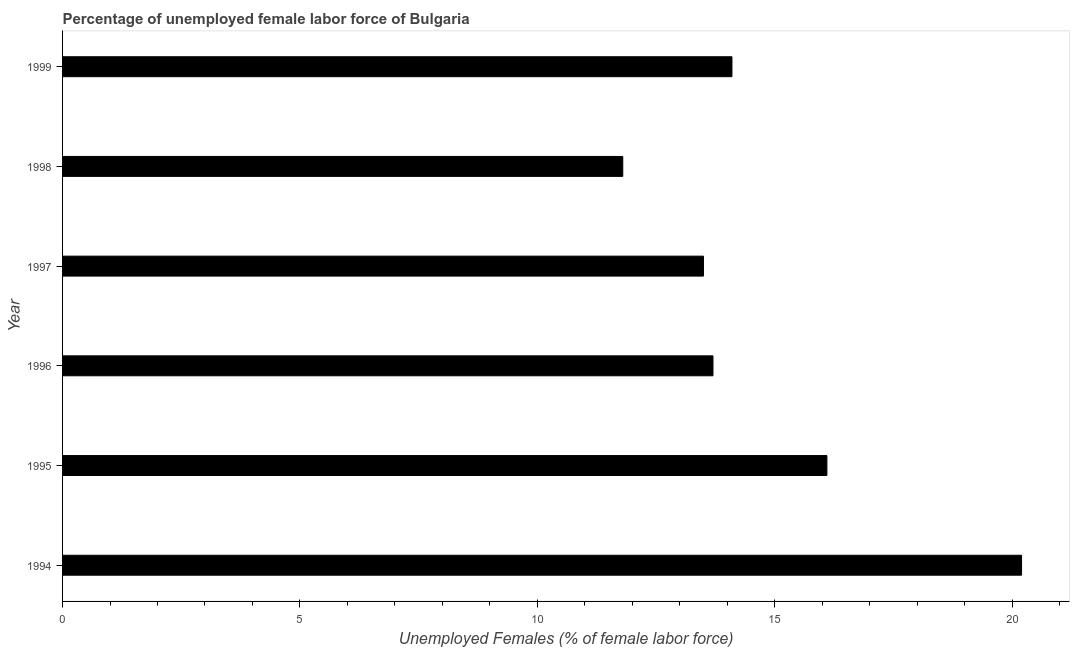Does the graph contain any zero values?
Provide a succinct answer. No. What is the title of the graph?
Provide a short and direct response. Percentage of unemployed female labor force of Bulgaria. What is the label or title of the X-axis?
Provide a short and direct response. Unemployed Females (% of female labor force). What is the total unemployed female labour force in 1998?
Your answer should be compact. 11.8. Across all years, what is the maximum total unemployed female labour force?
Provide a short and direct response. 20.2. Across all years, what is the minimum total unemployed female labour force?
Offer a very short reply. 11.8. In which year was the total unemployed female labour force maximum?
Offer a very short reply. 1994. What is the sum of the total unemployed female labour force?
Make the answer very short. 89.4. What is the average total unemployed female labour force per year?
Provide a short and direct response. 14.9. What is the median total unemployed female labour force?
Give a very brief answer. 13.9. In how many years, is the total unemployed female labour force greater than 4 %?
Ensure brevity in your answer.  6. What is the ratio of the total unemployed female labour force in 1994 to that in 1996?
Keep it short and to the point. 1.47. Is the difference between the total unemployed female labour force in 1996 and 1999 greater than the difference between any two years?
Ensure brevity in your answer.  No. What is the difference between the highest and the second highest total unemployed female labour force?
Your answer should be very brief. 4.1. Is the sum of the total unemployed female labour force in 1997 and 1999 greater than the maximum total unemployed female labour force across all years?
Your response must be concise. Yes. What is the difference between the highest and the lowest total unemployed female labour force?
Your answer should be compact. 8.4. In how many years, is the total unemployed female labour force greater than the average total unemployed female labour force taken over all years?
Offer a terse response. 2. Are all the bars in the graph horizontal?
Give a very brief answer. Yes. What is the difference between two consecutive major ticks on the X-axis?
Give a very brief answer. 5. Are the values on the major ticks of X-axis written in scientific E-notation?
Provide a succinct answer. No. What is the Unemployed Females (% of female labor force) in 1994?
Provide a succinct answer. 20.2. What is the Unemployed Females (% of female labor force) of 1995?
Your answer should be very brief. 16.1. What is the Unemployed Females (% of female labor force) in 1996?
Provide a short and direct response. 13.7. What is the Unemployed Females (% of female labor force) of 1998?
Provide a short and direct response. 11.8. What is the Unemployed Females (% of female labor force) of 1999?
Offer a terse response. 14.1. What is the difference between the Unemployed Females (% of female labor force) in 1994 and 1996?
Provide a succinct answer. 6.5. What is the difference between the Unemployed Females (% of female labor force) in 1994 and 1999?
Provide a succinct answer. 6.1. What is the difference between the Unemployed Females (% of female labor force) in 1995 and 1996?
Offer a terse response. 2.4. What is the difference between the Unemployed Females (% of female labor force) in 1995 and 1997?
Your response must be concise. 2.6. What is the difference between the Unemployed Females (% of female labor force) in 1996 and 1997?
Provide a short and direct response. 0.2. What is the difference between the Unemployed Females (% of female labor force) in 1996 and 1998?
Give a very brief answer. 1.9. What is the difference between the Unemployed Females (% of female labor force) in 1997 and 1998?
Make the answer very short. 1.7. What is the ratio of the Unemployed Females (% of female labor force) in 1994 to that in 1995?
Make the answer very short. 1.25. What is the ratio of the Unemployed Females (% of female labor force) in 1994 to that in 1996?
Give a very brief answer. 1.47. What is the ratio of the Unemployed Females (% of female labor force) in 1994 to that in 1997?
Your response must be concise. 1.5. What is the ratio of the Unemployed Females (% of female labor force) in 1994 to that in 1998?
Your answer should be very brief. 1.71. What is the ratio of the Unemployed Females (% of female labor force) in 1994 to that in 1999?
Offer a terse response. 1.43. What is the ratio of the Unemployed Females (% of female labor force) in 1995 to that in 1996?
Keep it short and to the point. 1.18. What is the ratio of the Unemployed Females (% of female labor force) in 1995 to that in 1997?
Provide a succinct answer. 1.19. What is the ratio of the Unemployed Females (% of female labor force) in 1995 to that in 1998?
Your answer should be compact. 1.36. What is the ratio of the Unemployed Females (% of female labor force) in 1995 to that in 1999?
Offer a very short reply. 1.14. What is the ratio of the Unemployed Females (% of female labor force) in 1996 to that in 1998?
Your response must be concise. 1.16. What is the ratio of the Unemployed Females (% of female labor force) in 1997 to that in 1998?
Give a very brief answer. 1.14. What is the ratio of the Unemployed Females (% of female labor force) in 1997 to that in 1999?
Keep it short and to the point. 0.96. What is the ratio of the Unemployed Females (% of female labor force) in 1998 to that in 1999?
Offer a very short reply. 0.84. 